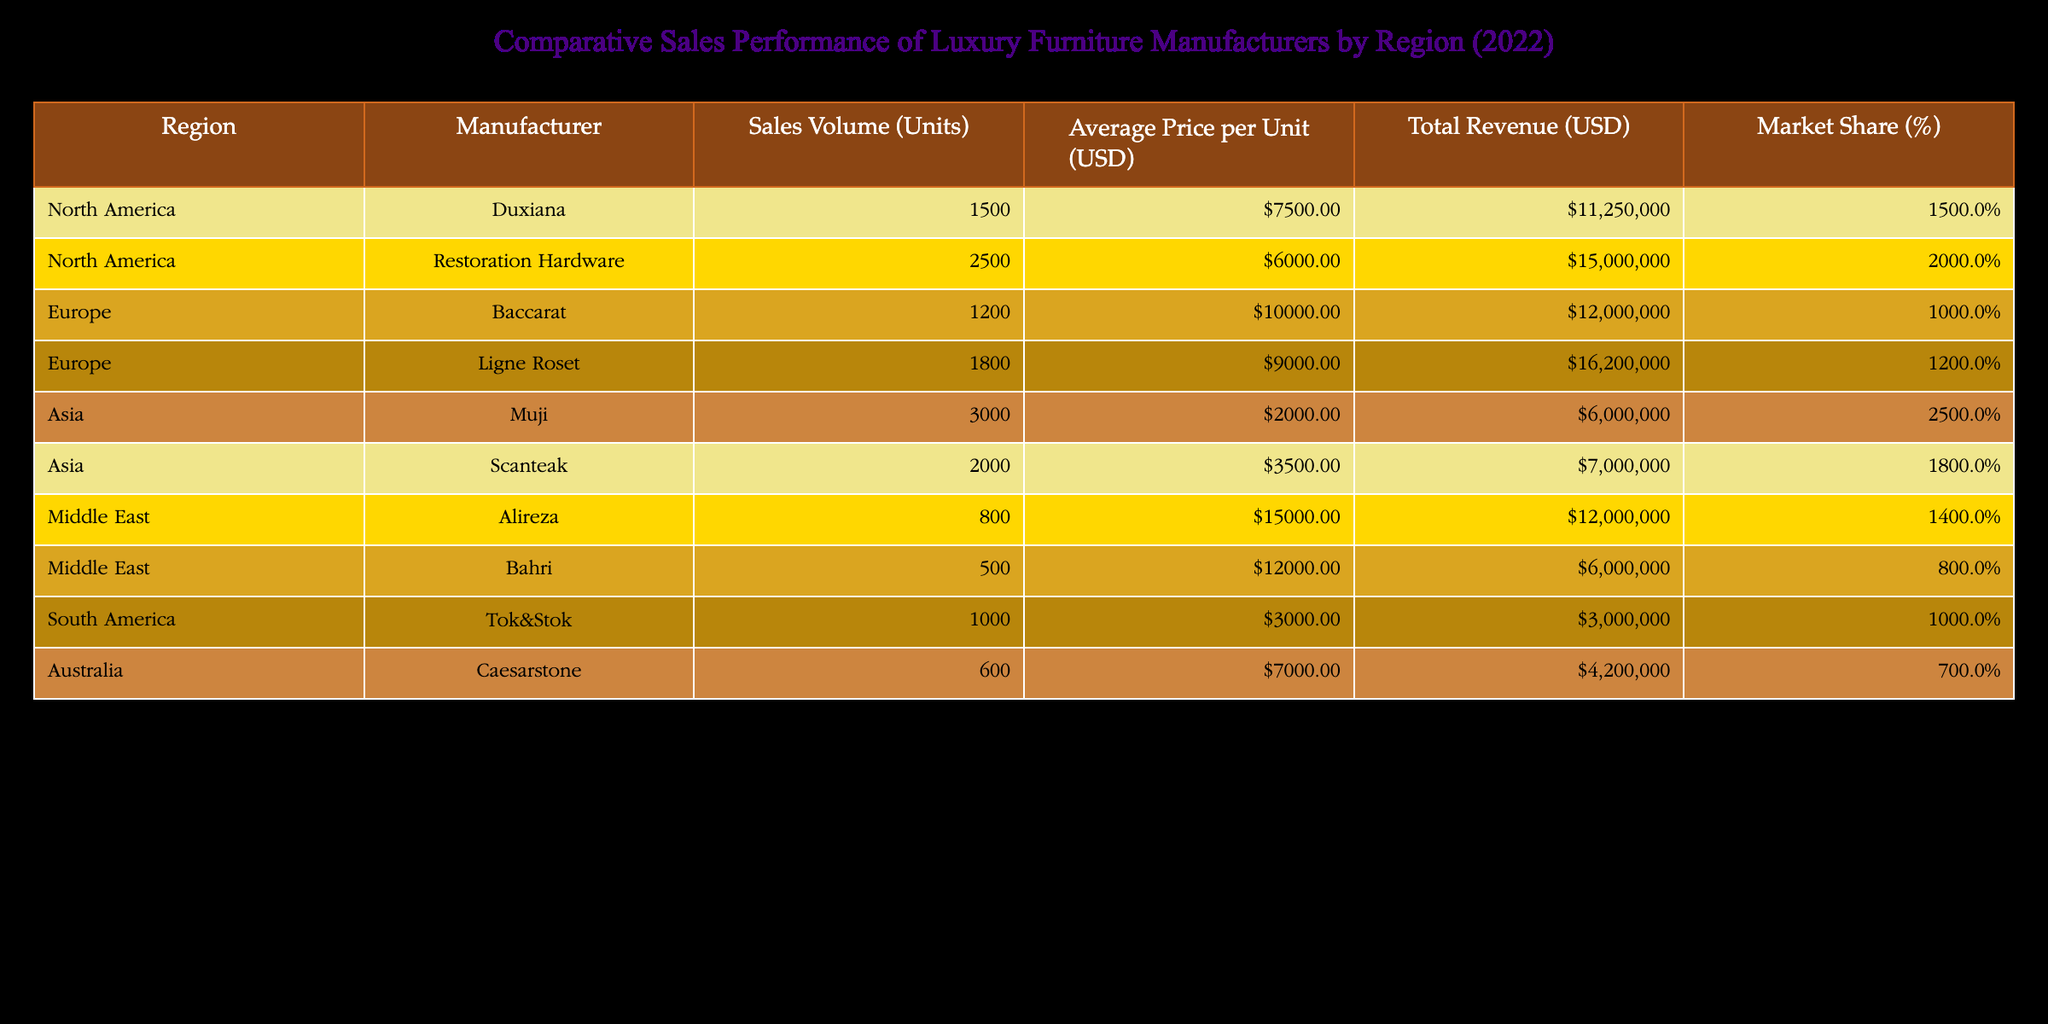What is the total sales volume for manufacturers in North America? The total sales volume for North America is calculated by adding the sales volumes of Duxiana and Restoration Hardware, which are 1500 units and 2500 units, respectively. Thus, 1500 + 2500 = 4000 units.
Answer: 4000 units Which manufacturer has the highest average price per unit? By comparing the Average Price per Unit column for all manufacturers, Alireza has the highest price at USD 15000.
Answer: Alireza What is the market share percentage of Scanteak in Asia? Scanteak's market share percentage is directly retrieved from the Market Share column for the Asia region, which is 18%.
Answer: 18% What is the total revenue generated by luxury furniture manufacturers in Europe? The total revenue for Europe is found by adding the total revenue of Baccarat (USD 12000000) and Ligne Roset (USD 16200000). Therefore, 12000000 + 16200000 = 28200000 USD.
Answer: 28200000 USD Is the total revenue of Muji greater than the total revenue of Tok&Stok? The total revenue of Muji is USD 6000000, while the total revenue of Tok&Stok is USD 3000000. Comparing these amounts, 6000000 > 3000000, thus Muji's revenue is greater.
Answer: Yes What is the average market share percentage of the manufacturers listed in the Middle East? To find the average market share for the Middle East, we sum the market shares of Alireza (14%) and Bahri (8%), giving 14 + 8 = 22%. We then divide by the number of manufacturers to find the average, 22% / 2 = 11%.
Answer: 11% Which region has the lowest average price per unit among the manufacturers? We need to examine the Average Price per Unit column across regions. Asia has the lowest average price, with Muji at USD 2000 and Scanteak at USD 3500. The average then is (2000 + 3500) / 2 = USD 2750, which is lower than any other region's average.
Answer: Asia What is the difference in total revenue between Restoration Hardware and Alireza? Restoration Hardware's total revenue is USD 15000000 and Alireza's total revenue is USD 12000000. The difference is calculated as 15000000 - 12000000 = USD 3000000.
Answer: 3000000 USD 